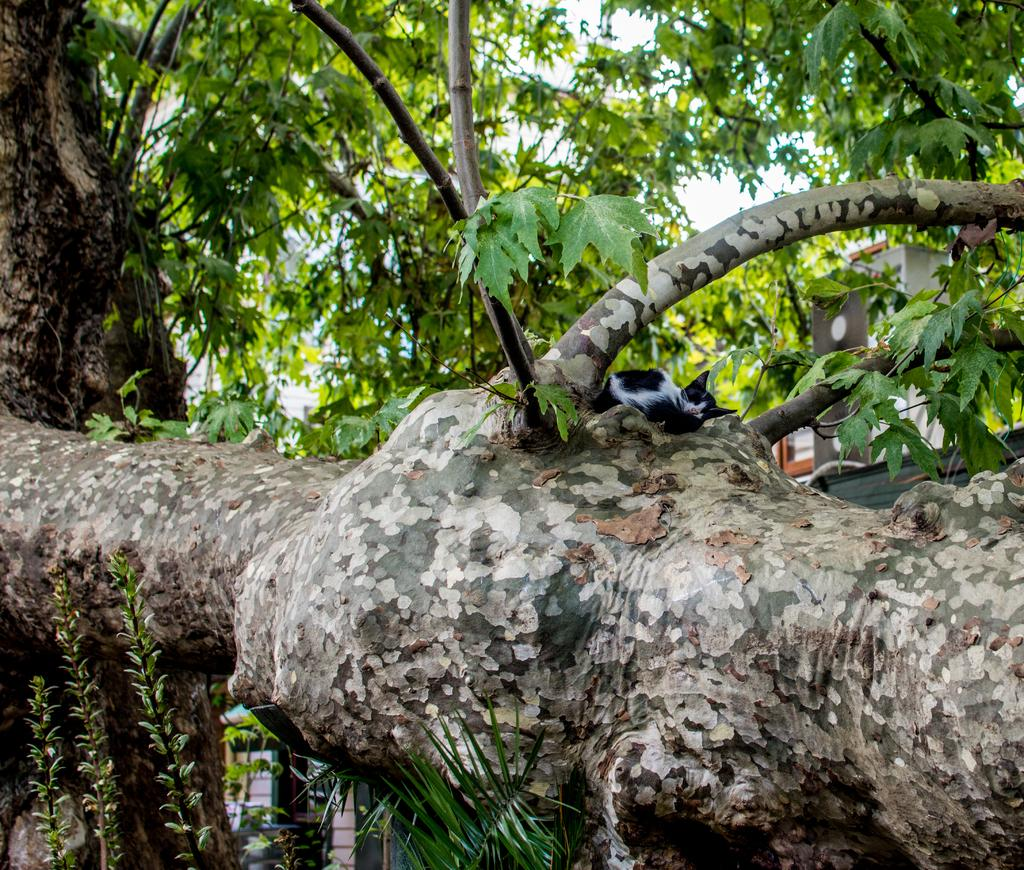What is the main subject in the image? There is a tree in the image. Is there any other living creature present in the image? Yes, there is a cat on the tree in the image. What type of chicken can be seen playing with the cat on the tree in the image? There is no chicken present in the image, and the cat is not playing with any chicken. 